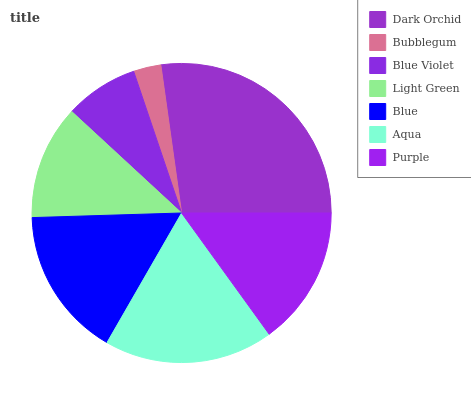Is Bubblegum the minimum?
Answer yes or no. Yes. Is Dark Orchid the maximum?
Answer yes or no. Yes. Is Blue Violet the minimum?
Answer yes or no. No. Is Blue Violet the maximum?
Answer yes or no. No. Is Blue Violet greater than Bubblegum?
Answer yes or no. Yes. Is Bubblegum less than Blue Violet?
Answer yes or no. Yes. Is Bubblegum greater than Blue Violet?
Answer yes or no. No. Is Blue Violet less than Bubblegum?
Answer yes or no. No. Is Purple the high median?
Answer yes or no. Yes. Is Purple the low median?
Answer yes or no. Yes. Is Dark Orchid the high median?
Answer yes or no. No. Is Bubblegum the low median?
Answer yes or no. No. 